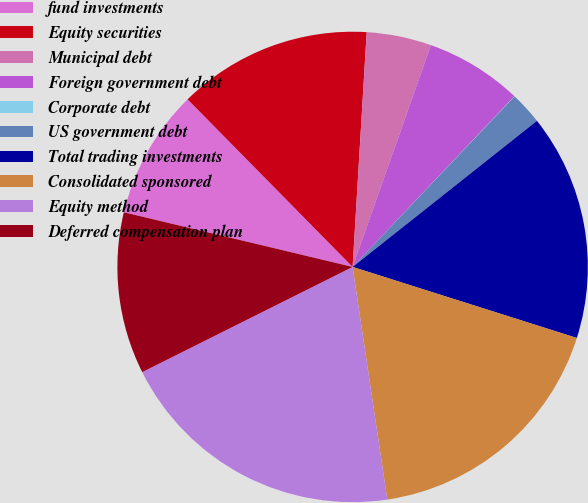<chart> <loc_0><loc_0><loc_500><loc_500><pie_chart><fcel>fund investments<fcel>Equity securities<fcel>Municipal debt<fcel>Foreign government debt<fcel>Corporate debt<fcel>US government debt<fcel>Total trading investments<fcel>Consolidated sponsored<fcel>Equity method<fcel>Deferred compensation plan<nl><fcel>8.89%<fcel>13.33%<fcel>4.45%<fcel>6.67%<fcel>0.02%<fcel>2.24%<fcel>15.55%<fcel>17.76%<fcel>19.98%<fcel>11.11%<nl></chart> 